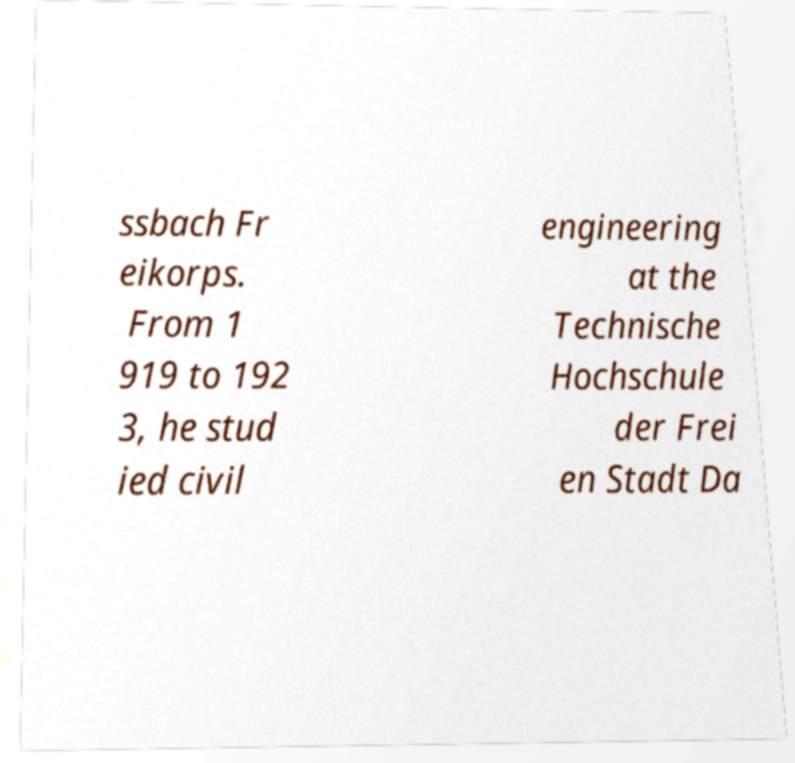Can you read and provide the text displayed in the image?This photo seems to have some interesting text. Can you extract and type it out for me? ssbach Fr eikorps. From 1 919 to 192 3, he stud ied civil engineering at the Technische Hochschule der Frei en Stadt Da 